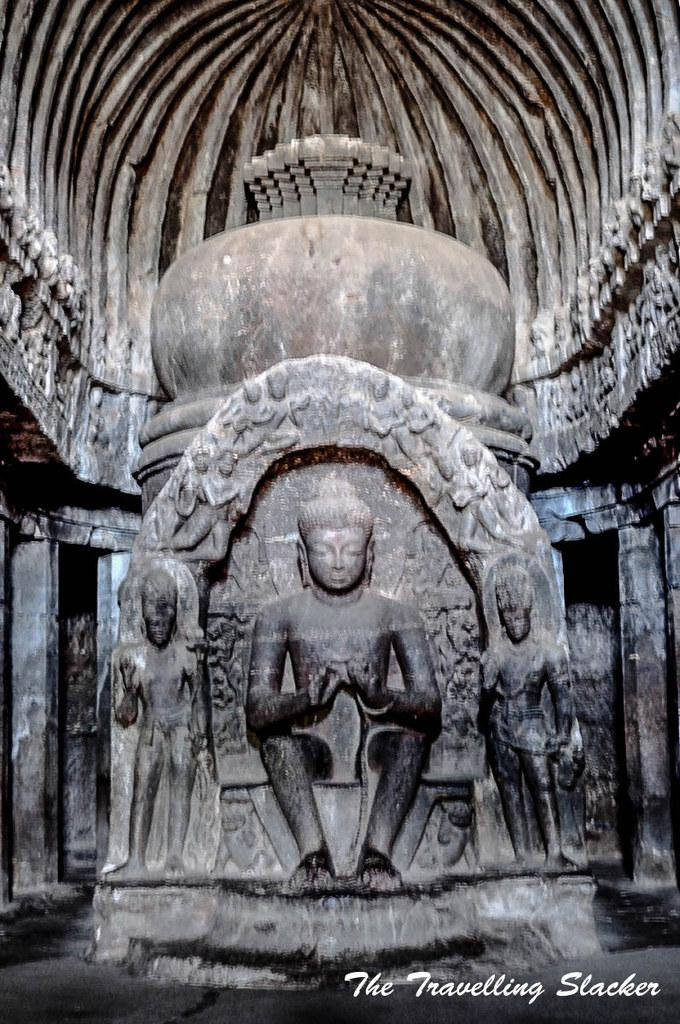What is the main subject of the image? There is a sculpture in the image. What can be seen on the backside of the sculpture? There are pillars and a wall visible on the backside of the sculpture. How does the sculpture provide comfort to the viewer in the image? The sculpture does not provide comfort to the viewer in the image, as it is an inanimate object. 